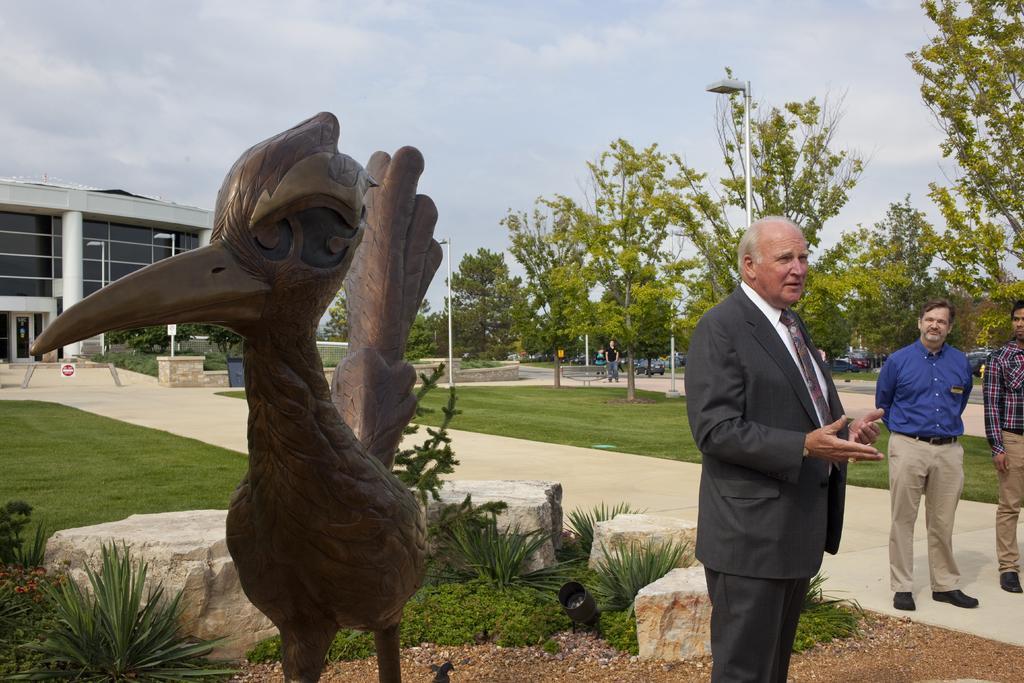How would you summarize this image in a sentence or two? In this image in the foreground there is one person who is standing and he is talking, and on the right side there are two persons who are standing. On the left side there is one statue and in the background there are some buildings, trees, poles, lights and some persons and also there are some vehicles. At the bottom there are some plants, grass, rocks and sand. In the center there is a walkway, on the top of the image there is sky. 